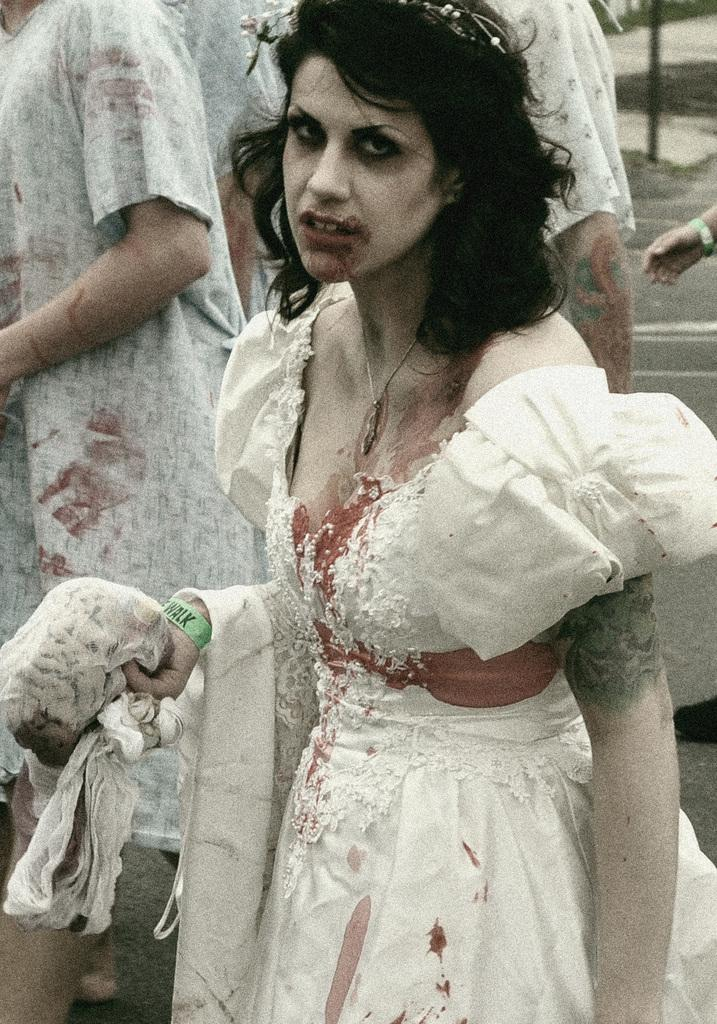Who or what can be seen in the image? There are people in the image. What is the lady in the image doing? A lady is holding an object in the image. Can you describe the object at the top right of the image? There is an object at the top right of the image, but its description is not provided in the facts. How many oranges are visible in the image? There is no mention of oranges in the image, so it is not possible to determine their presence or quantity. 